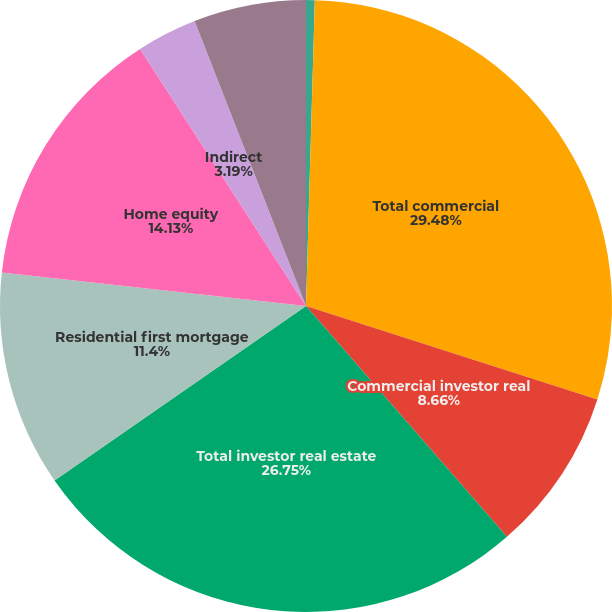Convert chart to OTSL. <chart><loc_0><loc_0><loc_500><loc_500><pie_chart><fcel>Commercial real estate<fcel>Total commercial<fcel>Commercial investor real<fcel>Total investor real estate<fcel>Residential first mortgage<fcel>Home equity<fcel>Indirect<fcel>Other consumer<nl><fcel>0.46%<fcel>29.48%<fcel>8.66%<fcel>26.75%<fcel>11.4%<fcel>14.13%<fcel>3.19%<fcel>5.93%<nl></chart> 